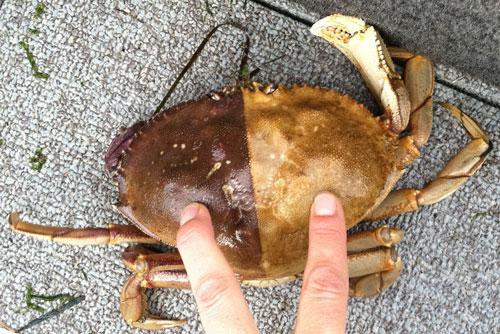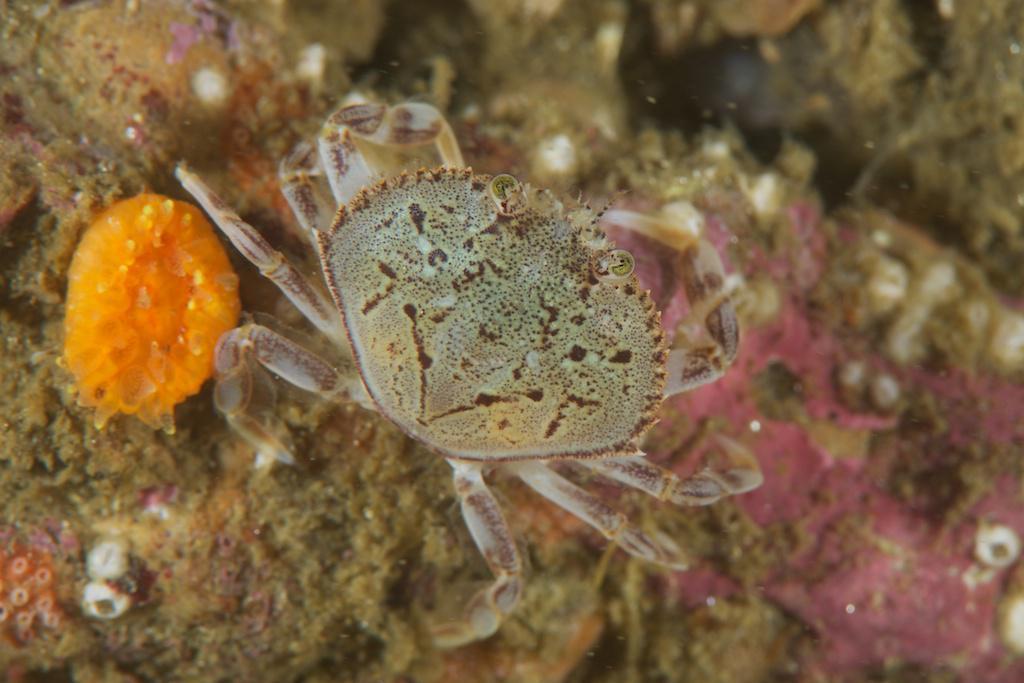The first image is the image on the left, the second image is the image on the right. Evaluate the accuracy of this statement regarding the images: "The left image contains a human touching a crab.". Is it true? Answer yes or no. Yes. The first image is the image on the left, the second image is the image on the right. Given the left and right images, does the statement "In at least one image there is a hand touching a crab." hold true? Answer yes or no. Yes. 